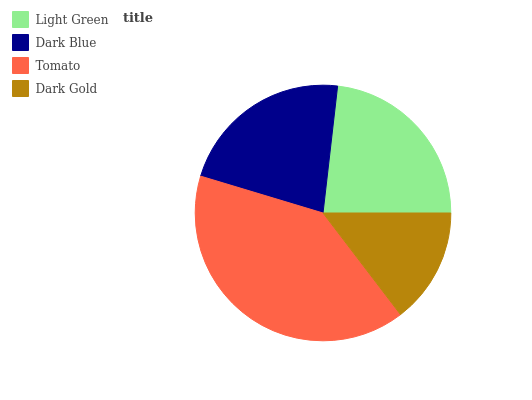Is Dark Gold the minimum?
Answer yes or no. Yes. Is Tomato the maximum?
Answer yes or no. Yes. Is Dark Blue the minimum?
Answer yes or no. No. Is Dark Blue the maximum?
Answer yes or no. No. Is Light Green greater than Dark Blue?
Answer yes or no. Yes. Is Dark Blue less than Light Green?
Answer yes or no. Yes. Is Dark Blue greater than Light Green?
Answer yes or no. No. Is Light Green less than Dark Blue?
Answer yes or no. No. Is Light Green the high median?
Answer yes or no. Yes. Is Dark Blue the low median?
Answer yes or no. Yes. Is Tomato the high median?
Answer yes or no. No. Is Tomato the low median?
Answer yes or no. No. 